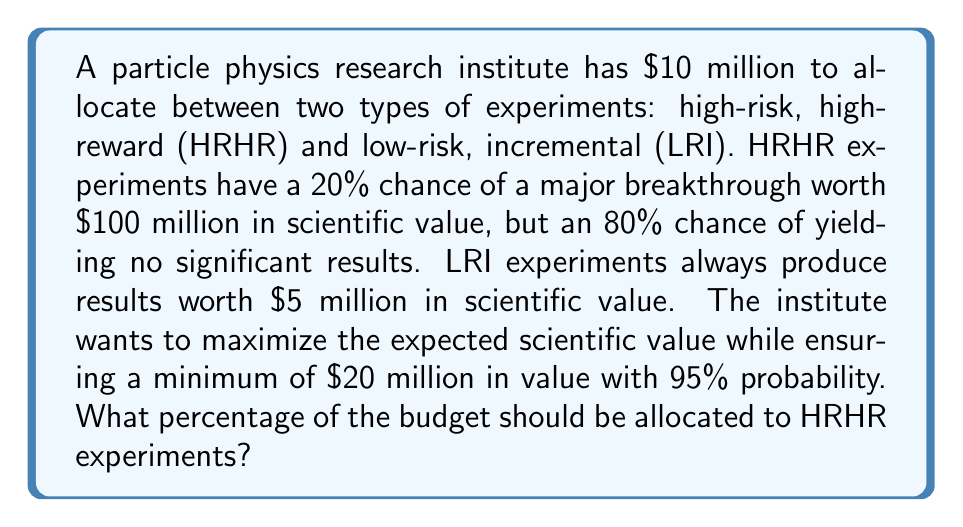What is the answer to this math problem? Let's approach this step-by-step:

1) Let $x$ be the fraction of the budget allocated to HRHR experiments. Then $(1-x)$ is the fraction allocated to LRI experiments.

2) Expected value of HRHR experiments:
   $E_{HRHR} = 10x \cdot (0.2 \cdot 100 + 0.8 \cdot 0) = 200x$ million

3) Expected value of LRI experiments:
   $E_{LRI} = 10(1-x) \cdot 5 = 50(1-x)$ million

4) Total expected value:
   $E_{total} = 200x + 50(1-x) = 200x + 50 - 50x = 150x + 50$ million

5) To ensure a minimum of $20 million with 95% probability, we need to consider the worst-case scenario where HRHR experiments fail (80% chance). The value in this case should be at least $20 million:

   $10(1-x) \cdot 5 \geq 20$
   $50 - 50x \geq 20$
   $30 \geq 50x$
   $x \leq 0.6$

6) Now, we want to maximize $E_{total} = 150x + 50$ subject to $x \leq 0.6$

   Since the coefficient of $x$ is positive, the maximum occurs at the upper bound of $x$, which is 0.6.

7) Therefore, the optimal allocation is 60% to HRHR experiments and 40% to LRI experiments.

8) We can verify:
   - Expected value: $150(0.6) + 50 = 140$ million
   - Minimum value with 95% probability: $10(0.4) \cdot 5 = 20$ million
Answer: 60% of the budget should be allocated to high-risk, high-reward experiments. 